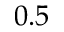<formula> <loc_0><loc_0><loc_500><loc_500>0 . 5</formula> 